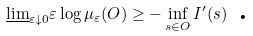<formula> <loc_0><loc_0><loc_500><loc_500>\underline { \lim } _ { \varepsilon \downarrow 0 } \varepsilon \log \mu _ { \varepsilon } ( O ) \geq - \inf _ { s \in O } I ^ { \prime } ( s ) \text { .}</formula> 